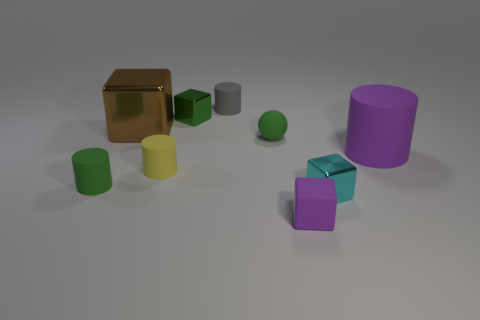Are there any repeating patterns or symmetry in the composition of these objects? While there is no explicit repeating pattern, there is a symmetry in terms of shapes – there are multiple cylinders and cubes in the scene. However, their arrangement appears random, lacking a deliberate symmetric composition.  Does the arrangement of the objects suggest any particular theme or idea? The arrangement doesn’t convey a clear theme but the juxtaposition of geometric shapes in different sizes and colors could imply diversity or variation. The randomness may also suggest a theme of disorder or an organic, unstructured aesthetic. 